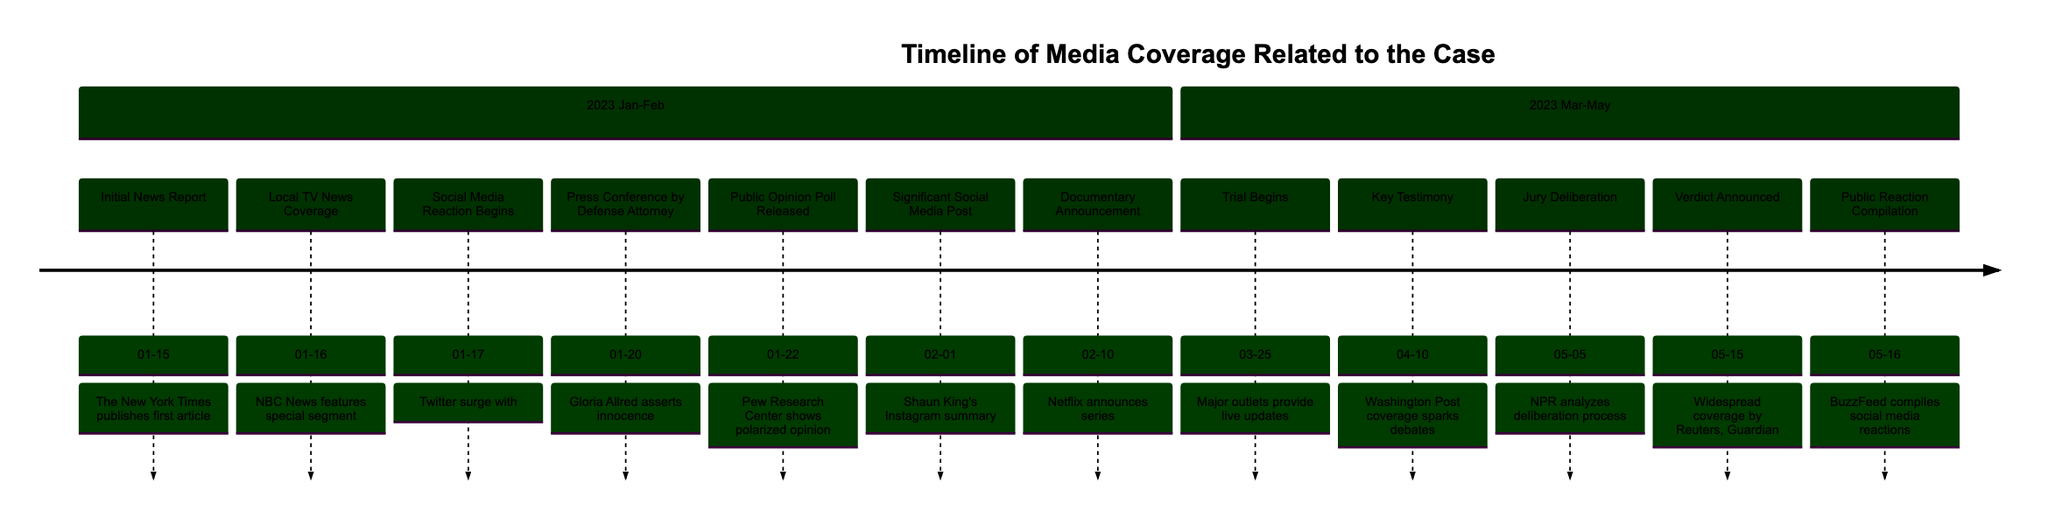What is the date of the initial news report? The initial news report is dated 2023-01-15, as specified in the timeline's first event.
Answer: 2023-01-15 Which media outlet published the first article about the alleged crime? The diagram indicates that The New York Times published the first article, which is mentioned as part of the initial news report.
Answer: The New York Times How many events are listed in January 2023? The timeline includes six events within January 2023, counting each one depicted from the 15th to the 22nd.
Answer: 6 What event occurred right after the public opinion poll? The event that occurred immediately after the public opinion poll on 2023-01-22 is the significant social media post by Shaun King on 2023-02-01.
Answer: Significant Social Media Post What was the public's reaction on social media regarding the accused? The public's reaction on social media began with a surge in posts under the hashtag #JusticeForAccused, detailing mixed reactions.
Answer: #JusticeForAccused Which event sparked debates on social media? The key testimony covered by The Washington Post on 2023-04-10 sparked debates on social media, as noted in the timeline entry.
Answer: Key Testimony What significant announcement was made on February 10, 2023? The significant announcement made was by Netflix, which announced a documentary series focusing on the case, marking it as noteworthy media coverage.
Answer: Documentary Announcement What event marks the beginning of the trial? The trial begins on 2023-03-25, as denoted in the timeline, with major media outlets providing live updates on that date.
Answer: Trial Begins What was the outcome discussed on 2023-05-15? The outcome discussed was the verdict announcement, which resulted in widespread media coverage and public discussions regarding the case outcome.
Answer: Verdict Announced 